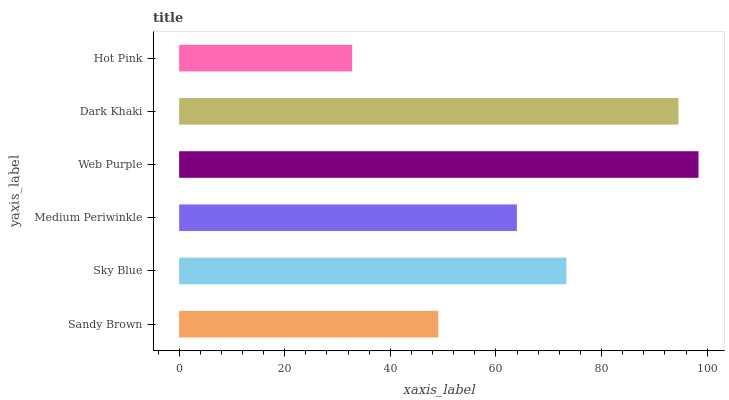Is Hot Pink the minimum?
Answer yes or no. Yes. Is Web Purple the maximum?
Answer yes or no. Yes. Is Sky Blue the minimum?
Answer yes or no. No. Is Sky Blue the maximum?
Answer yes or no. No. Is Sky Blue greater than Sandy Brown?
Answer yes or no. Yes. Is Sandy Brown less than Sky Blue?
Answer yes or no. Yes. Is Sandy Brown greater than Sky Blue?
Answer yes or no. No. Is Sky Blue less than Sandy Brown?
Answer yes or no. No. Is Sky Blue the high median?
Answer yes or no. Yes. Is Medium Periwinkle the low median?
Answer yes or no. Yes. Is Hot Pink the high median?
Answer yes or no. No. Is Dark Khaki the low median?
Answer yes or no. No. 